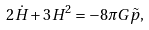<formula> <loc_0><loc_0><loc_500><loc_500>2 \dot { H } + 3 H ^ { 2 } = - 8 \pi G \tilde { p } ,</formula> 